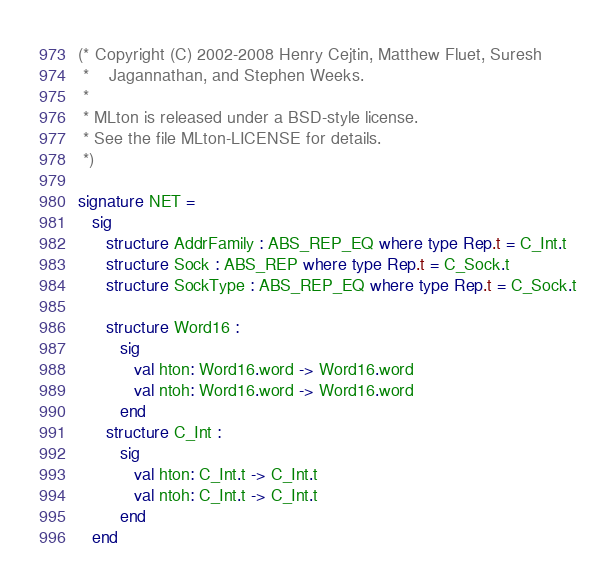Convert code to text. <code><loc_0><loc_0><loc_500><loc_500><_SML_>(* Copyright (C) 2002-2008 Henry Cejtin, Matthew Fluet, Suresh
 *    Jagannathan, and Stephen Weeks.
 *
 * MLton is released under a BSD-style license.
 * See the file MLton-LICENSE for details.
 *)

signature NET =
   sig
      structure AddrFamily : ABS_REP_EQ where type Rep.t = C_Int.t
      structure Sock : ABS_REP where type Rep.t = C_Sock.t
      structure SockType : ABS_REP_EQ where type Rep.t = C_Sock.t

      structure Word16 :
         sig
            val hton: Word16.word -> Word16.word
            val ntoh: Word16.word -> Word16.word
         end
      structure C_Int :
         sig
            val hton: C_Int.t -> C_Int.t
            val ntoh: C_Int.t -> C_Int.t
         end
   end
</code> 